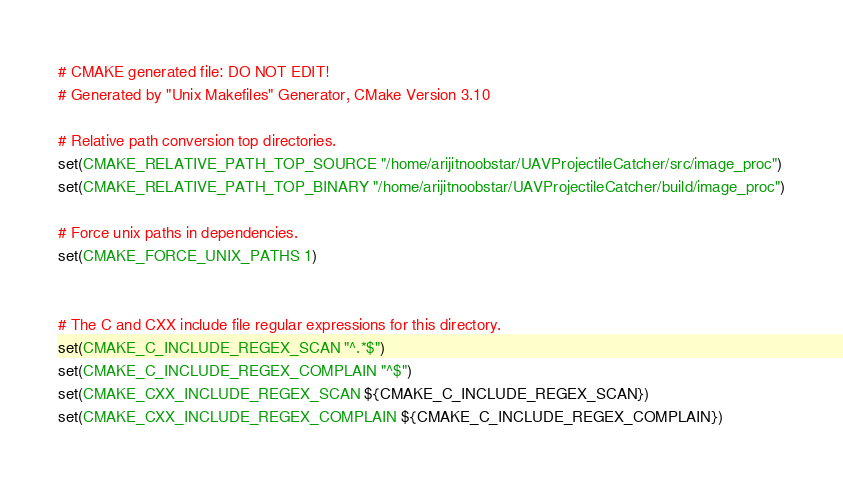<code> <loc_0><loc_0><loc_500><loc_500><_CMake_># CMAKE generated file: DO NOT EDIT!
# Generated by "Unix Makefiles" Generator, CMake Version 3.10

# Relative path conversion top directories.
set(CMAKE_RELATIVE_PATH_TOP_SOURCE "/home/arijitnoobstar/UAVProjectileCatcher/src/image_proc")
set(CMAKE_RELATIVE_PATH_TOP_BINARY "/home/arijitnoobstar/UAVProjectileCatcher/build/image_proc")

# Force unix paths in dependencies.
set(CMAKE_FORCE_UNIX_PATHS 1)


# The C and CXX include file regular expressions for this directory.
set(CMAKE_C_INCLUDE_REGEX_SCAN "^.*$")
set(CMAKE_C_INCLUDE_REGEX_COMPLAIN "^$")
set(CMAKE_CXX_INCLUDE_REGEX_SCAN ${CMAKE_C_INCLUDE_REGEX_SCAN})
set(CMAKE_CXX_INCLUDE_REGEX_COMPLAIN ${CMAKE_C_INCLUDE_REGEX_COMPLAIN})
</code> 